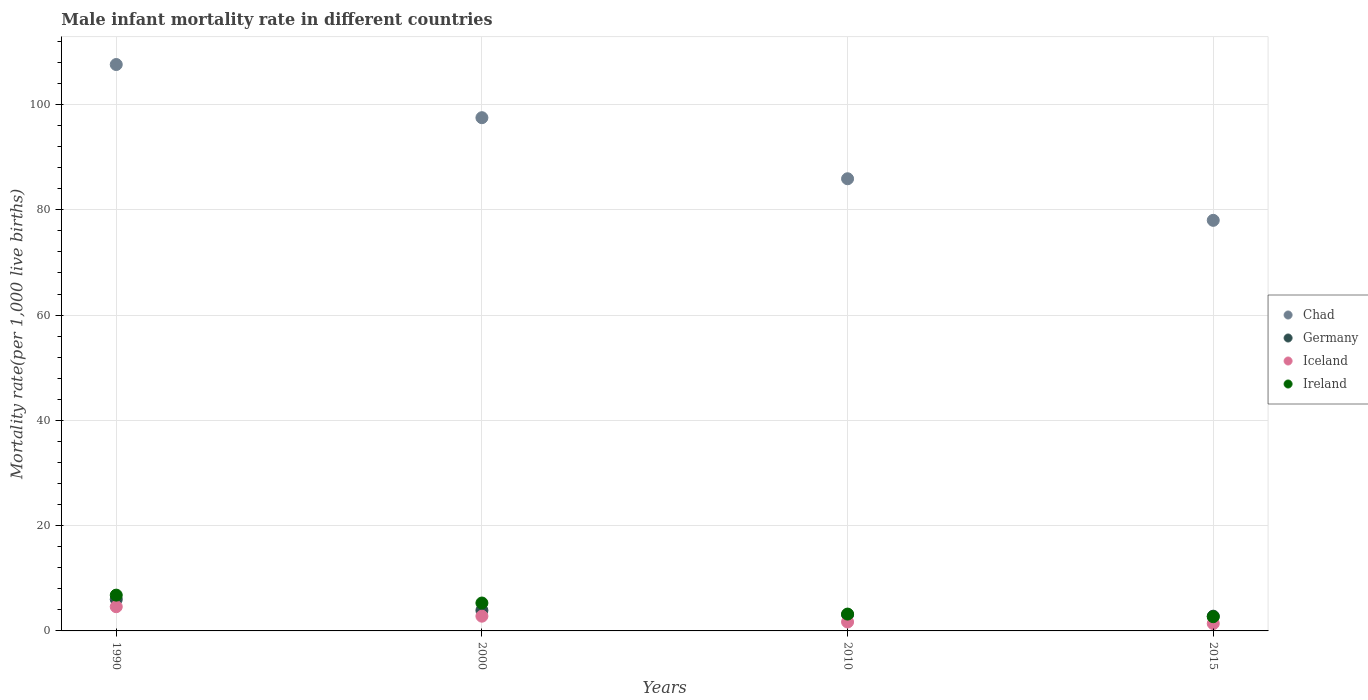What is the male infant mortality rate in Chad in 2010?
Offer a very short reply. 85.9. Across all years, what is the maximum male infant mortality rate in Iceland?
Your answer should be very brief. 4.6. Across all years, what is the minimum male infant mortality rate in Chad?
Provide a short and direct response. 78. In which year was the male infant mortality rate in Germany minimum?
Provide a short and direct response. 2015. What is the total male infant mortality rate in Germany in the graph?
Your answer should be compact. 15.8. What is the difference between the male infant mortality rate in Germany in 1990 and that in 2000?
Your response must be concise. 2.1. What is the difference between the male infant mortality rate in Ireland in 2000 and the male infant mortality rate in Iceland in 2010?
Keep it short and to the point. 3.6. What is the average male infant mortality rate in Chad per year?
Provide a short and direct response. 92.25. In the year 2015, what is the difference between the male infant mortality rate in Germany and male infant mortality rate in Ireland?
Offer a terse response. 0.1. In how many years, is the male infant mortality rate in Ireland greater than 52?
Provide a succinct answer. 0. What is the ratio of the male infant mortality rate in Germany in 1990 to that in 2015?
Your response must be concise. 2.14. Is the male infant mortality rate in Ireland in 1990 less than that in 2010?
Your answer should be very brief. No. Is the difference between the male infant mortality rate in Germany in 2000 and 2010 greater than the difference between the male infant mortality rate in Ireland in 2000 and 2010?
Keep it short and to the point. No. What is the difference between the highest and the second highest male infant mortality rate in Chad?
Your answer should be compact. 10.1. In how many years, is the male infant mortality rate in Iceland greater than the average male infant mortality rate in Iceland taken over all years?
Keep it short and to the point. 2. Is it the case that in every year, the sum of the male infant mortality rate in Ireland and male infant mortality rate in Chad  is greater than the sum of male infant mortality rate in Iceland and male infant mortality rate in Germany?
Your response must be concise. Yes. Does the male infant mortality rate in Germany monotonically increase over the years?
Make the answer very short. No. Is the male infant mortality rate in Chad strictly greater than the male infant mortality rate in Iceland over the years?
Give a very brief answer. Yes. How many dotlines are there?
Provide a short and direct response. 4. How many years are there in the graph?
Offer a very short reply. 4. Does the graph contain any zero values?
Offer a terse response. No. Does the graph contain grids?
Offer a very short reply. Yes. How many legend labels are there?
Your answer should be very brief. 4. How are the legend labels stacked?
Your response must be concise. Vertical. What is the title of the graph?
Ensure brevity in your answer.  Male infant mortality rate in different countries. What is the label or title of the Y-axis?
Keep it short and to the point. Mortality rate(per 1,0 live births). What is the Mortality rate(per 1,000 live births) in Chad in 1990?
Offer a very short reply. 107.6. What is the Mortality rate(per 1,000 live births) in Chad in 2000?
Your answer should be compact. 97.5. What is the Mortality rate(per 1,000 live births) in Iceland in 2000?
Offer a terse response. 2.8. What is the Mortality rate(per 1,000 live births) of Ireland in 2000?
Offer a very short reply. 5.3. What is the Mortality rate(per 1,000 live births) of Chad in 2010?
Ensure brevity in your answer.  85.9. What is the Mortality rate(per 1,000 live births) in Germany in 2010?
Offer a terse response. 3.1. What is the Mortality rate(per 1,000 live births) in Germany in 2015?
Provide a short and direct response. 2.8. Across all years, what is the maximum Mortality rate(per 1,000 live births) of Chad?
Give a very brief answer. 107.6. Across all years, what is the maximum Mortality rate(per 1,000 live births) of Iceland?
Ensure brevity in your answer.  4.6. Across all years, what is the minimum Mortality rate(per 1,000 live births) in Chad?
Your response must be concise. 78. What is the total Mortality rate(per 1,000 live births) of Chad in the graph?
Give a very brief answer. 369. What is the total Mortality rate(per 1,000 live births) of Germany in the graph?
Offer a terse response. 15.8. What is the total Mortality rate(per 1,000 live births) of Iceland in the graph?
Your answer should be compact. 10.5. What is the difference between the Mortality rate(per 1,000 live births) in Chad in 1990 and that in 2000?
Make the answer very short. 10.1. What is the difference between the Mortality rate(per 1,000 live births) of Germany in 1990 and that in 2000?
Offer a very short reply. 2.1. What is the difference between the Mortality rate(per 1,000 live births) in Ireland in 1990 and that in 2000?
Your answer should be very brief. 1.5. What is the difference between the Mortality rate(per 1,000 live births) of Chad in 1990 and that in 2010?
Your response must be concise. 21.7. What is the difference between the Mortality rate(per 1,000 live births) in Iceland in 1990 and that in 2010?
Your response must be concise. 2.9. What is the difference between the Mortality rate(per 1,000 live births) of Ireland in 1990 and that in 2010?
Offer a terse response. 3.6. What is the difference between the Mortality rate(per 1,000 live births) in Chad in 1990 and that in 2015?
Your answer should be very brief. 29.6. What is the difference between the Mortality rate(per 1,000 live births) of Germany in 1990 and that in 2015?
Offer a very short reply. 3.2. What is the difference between the Mortality rate(per 1,000 live births) in Germany in 2000 and that in 2010?
Your response must be concise. 0.8. What is the difference between the Mortality rate(per 1,000 live births) in Ireland in 2000 and that in 2010?
Your response must be concise. 2.1. What is the difference between the Mortality rate(per 1,000 live births) of Germany in 2010 and that in 2015?
Provide a short and direct response. 0.3. What is the difference between the Mortality rate(per 1,000 live births) in Ireland in 2010 and that in 2015?
Provide a succinct answer. 0.5. What is the difference between the Mortality rate(per 1,000 live births) in Chad in 1990 and the Mortality rate(per 1,000 live births) in Germany in 2000?
Keep it short and to the point. 103.7. What is the difference between the Mortality rate(per 1,000 live births) of Chad in 1990 and the Mortality rate(per 1,000 live births) of Iceland in 2000?
Your response must be concise. 104.8. What is the difference between the Mortality rate(per 1,000 live births) in Chad in 1990 and the Mortality rate(per 1,000 live births) in Ireland in 2000?
Make the answer very short. 102.3. What is the difference between the Mortality rate(per 1,000 live births) in Germany in 1990 and the Mortality rate(per 1,000 live births) in Ireland in 2000?
Offer a terse response. 0.7. What is the difference between the Mortality rate(per 1,000 live births) in Chad in 1990 and the Mortality rate(per 1,000 live births) in Germany in 2010?
Your answer should be very brief. 104.5. What is the difference between the Mortality rate(per 1,000 live births) in Chad in 1990 and the Mortality rate(per 1,000 live births) in Iceland in 2010?
Make the answer very short. 105.9. What is the difference between the Mortality rate(per 1,000 live births) in Chad in 1990 and the Mortality rate(per 1,000 live births) in Ireland in 2010?
Keep it short and to the point. 104.4. What is the difference between the Mortality rate(per 1,000 live births) in Germany in 1990 and the Mortality rate(per 1,000 live births) in Iceland in 2010?
Your answer should be very brief. 4.3. What is the difference between the Mortality rate(per 1,000 live births) of Iceland in 1990 and the Mortality rate(per 1,000 live births) of Ireland in 2010?
Make the answer very short. 1.4. What is the difference between the Mortality rate(per 1,000 live births) of Chad in 1990 and the Mortality rate(per 1,000 live births) of Germany in 2015?
Offer a terse response. 104.8. What is the difference between the Mortality rate(per 1,000 live births) in Chad in 1990 and the Mortality rate(per 1,000 live births) in Iceland in 2015?
Give a very brief answer. 106.2. What is the difference between the Mortality rate(per 1,000 live births) in Chad in 1990 and the Mortality rate(per 1,000 live births) in Ireland in 2015?
Offer a terse response. 104.9. What is the difference between the Mortality rate(per 1,000 live births) of Germany in 1990 and the Mortality rate(per 1,000 live births) of Iceland in 2015?
Provide a succinct answer. 4.6. What is the difference between the Mortality rate(per 1,000 live births) in Germany in 1990 and the Mortality rate(per 1,000 live births) in Ireland in 2015?
Provide a succinct answer. 3.3. What is the difference between the Mortality rate(per 1,000 live births) in Iceland in 1990 and the Mortality rate(per 1,000 live births) in Ireland in 2015?
Make the answer very short. 1.9. What is the difference between the Mortality rate(per 1,000 live births) of Chad in 2000 and the Mortality rate(per 1,000 live births) of Germany in 2010?
Your response must be concise. 94.4. What is the difference between the Mortality rate(per 1,000 live births) in Chad in 2000 and the Mortality rate(per 1,000 live births) in Iceland in 2010?
Your answer should be compact. 95.8. What is the difference between the Mortality rate(per 1,000 live births) in Chad in 2000 and the Mortality rate(per 1,000 live births) in Ireland in 2010?
Your answer should be compact. 94.3. What is the difference between the Mortality rate(per 1,000 live births) in Germany in 2000 and the Mortality rate(per 1,000 live births) in Iceland in 2010?
Provide a succinct answer. 2.2. What is the difference between the Mortality rate(per 1,000 live births) in Germany in 2000 and the Mortality rate(per 1,000 live births) in Ireland in 2010?
Keep it short and to the point. 0.7. What is the difference between the Mortality rate(per 1,000 live births) in Chad in 2000 and the Mortality rate(per 1,000 live births) in Germany in 2015?
Offer a very short reply. 94.7. What is the difference between the Mortality rate(per 1,000 live births) in Chad in 2000 and the Mortality rate(per 1,000 live births) in Iceland in 2015?
Your answer should be compact. 96.1. What is the difference between the Mortality rate(per 1,000 live births) in Chad in 2000 and the Mortality rate(per 1,000 live births) in Ireland in 2015?
Provide a short and direct response. 94.8. What is the difference between the Mortality rate(per 1,000 live births) of Iceland in 2000 and the Mortality rate(per 1,000 live births) of Ireland in 2015?
Give a very brief answer. 0.1. What is the difference between the Mortality rate(per 1,000 live births) in Chad in 2010 and the Mortality rate(per 1,000 live births) in Germany in 2015?
Give a very brief answer. 83.1. What is the difference between the Mortality rate(per 1,000 live births) in Chad in 2010 and the Mortality rate(per 1,000 live births) in Iceland in 2015?
Keep it short and to the point. 84.5. What is the difference between the Mortality rate(per 1,000 live births) of Chad in 2010 and the Mortality rate(per 1,000 live births) of Ireland in 2015?
Give a very brief answer. 83.2. What is the average Mortality rate(per 1,000 live births) of Chad per year?
Give a very brief answer. 92.25. What is the average Mortality rate(per 1,000 live births) of Germany per year?
Keep it short and to the point. 3.95. What is the average Mortality rate(per 1,000 live births) in Iceland per year?
Give a very brief answer. 2.62. What is the average Mortality rate(per 1,000 live births) of Ireland per year?
Give a very brief answer. 4.5. In the year 1990, what is the difference between the Mortality rate(per 1,000 live births) in Chad and Mortality rate(per 1,000 live births) in Germany?
Ensure brevity in your answer.  101.6. In the year 1990, what is the difference between the Mortality rate(per 1,000 live births) in Chad and Mortality rate(per 1,000 live births) in Iceland?
Your answer should be very brief. 103. In the year 1990, what is the difference between the Mortality rate(per 1,000 live births) of Chad and Mortality rate(per 1,000 live births) of Ireland?
Provide a succinct answer. 100.8. In the year 1990, what is the difference between the Mortality rate(per 1,000 live births) of Germany and Mortality rate(per 1,000 live births) of Iceland?
Offer a very short reply. 1.4. In the year 2000, what is the difference between the Mortality rate(per 1,000 live births) in Chad and Mortality rate(per 1,000 live births) in Germany?
Offer a very short reply. 93.6. In the year 2000, what is the difference between the Mortality rate(per 1,000 live births) of Chad and Mortality rate(per 1,000 live births) of Iceland?
Keep it short and to the point. 94.7. In the year 2000, what is the difference between the Mortality rate(per 1,000 live births) of Chad and Mortality rate(per 1,000 live births) of Ireland?
Make the answer very short. 92.2. In the year 2000, what is the difference between the Mortality rate(per 1,000 live births) of Germany and Mortality rate(per 1,000 live births) of Iceland?
Offer a very short reply. 1.1. In the year 2000, what is the difference between the Mortality rate(per 1,000 live births) in Germany and Mortality rate(per 1,000 live births) in Ireland?
Provide a succinct answer. -1.4. In the year 2000, what is the difference between the Mortality rate(per 1,000 live births) of Iceland and Mortality rate(per 1,000 live births) of Ireland?
Your answer should be compact. -2.5. In the year 2010, what is the difference between the Mortality rate(per 1,000 live births) of Chad and Mortality rate(per 1,000 live births) of Germany?
Offer a terse response. 82.8. In the year 2010, what is the difference between the Mortality rate(per 1,000 live births) in Chad and Mortality rate(per 1,000 live births) in Iceland?
Your answer should be compact. 84.2. In the year 2010, what is the difference between the Mortality rate(per 1,000 live births) in Chad and Mortality rate(per 1,000 live births) in Ireland?
Keep it short and to the point. 82.7. In the year 2010, what is the difference between the Mortality rate(per 1,000 live births) in Germany and Mortality rate(per 1,000 live births) in Iceland?
Your answer should be compact. 1.4. In the year 2010, what is the difference between the Mortality rate(per 1,000 live births) of Germany and Mortality rate(per 1,000 live births) of Ireland?
Ensure brevity in your answer.  -0.1. In the year 2010, what is the difference between the Mortality rate(per 1,000 live births) of Iceland and Mortality rate(per 1,000 live births) of Ireland?
Make the answer very short. -1.5. In the year 2015, what is the difference between the Mortality rate(per 1,000 live births) in Chad and Mortality rate(per 1,000 live births) in Germany?
Offer a terse response. 75.2. In the year 2015, what is the difference between the Mortality rate(per 1,000 live births) in Chad and Mortality rate(per 1,000 live births) in Iceland?
Keep it short and to the point. 76.6. In the year 2015, what is the difference between the Mortality rate(per 1,000 live births) of Chad and Mortality rate(per 1,000 live births) of Ireland?
Your answer should be compact. 75.3. What is the ratio of the Mortality rate(per 1,000 live births) of Chad in 1990 to that in 2000?
Offer a very short reply. 1.1. What is the ratio of the Mortality rate(per 1,000 live births) of Germany in 1990 to that in 2000?
Your answer should be very brief. 1.54. What is the ratio of the Mortality rate(per 1,000 live births) of Iceland in 1990 to that in 2000?
Your answer should be compact. 1.64. What is the ratio of the Mortality rate(per 1,000 live births) of Ireland in 1990 to that in 2000?
Offer a terse response. 1.28. What is the ratio of the Mortality rate(per 1,000 live births) in Chad in 1990 to that in 2010?
Your answer should be very brief. 1.25. What is the ratio of the Mortality rate(per 1,000 live births) of Germany in 1990 to that in 2010?
Offer a very short reply. 1.94. What is the ratio of the Mortality rate(per 1,000 live births) of Iceland in 1990 to that in 2010?
Your answer should be very brief. 2.71. What is the ratio of the Mortality rate(per 1,000 live births) of Ireland in 1990 to that in 2010?
Your answer should be compact. 2.12. What is the ratio of the Mortality rate(per 1,000 live births) of Chad in 1990 to that in 2015?
Your answer should be very brief. 1.38. What is the ratio of the Mortality rate(per 1,000 live births) of Germany in 1990 to that in 2015?
Provide a short and direct response. 2.14. What is the ratio of the Mortality rate(per 1,000 live births) of Iceland in 1990 to that in 2015?
Your answer should be very brief. 3.29. What is the ratio of the Mortality rate(per 1,000 live births) in Ireland in 1990 to that in 2015?
Offer a terse response. 2.52. What is the ratio of the Mortality rate(per 1,000 live births) in Chad in 2000 to that in 2010?
Your answer should be compact. 1.14. What is the ratio of the Mortality rate(per 1,000 live births) of Germany in 2000 to that in 2010?
Make the answer very short. 1.26. What is the ratio of the Mortality rate(per 1,000 live births) in Iceland in 2000 to that in 2010?
Make the answer very short. 1.65. What is the ratio of the Mortality rate(per 1,000 live births) of Ireland in 2000 to that in 2010?
Your answer should be compact. 1.66. What is the ratio of the Mortality rate(per 1,000 live births) of Germany in 2000 to that in 2015?
Ensure brevity in your answer.  1.39. What is the ratio of the Mortality rate(per 1,000 live births) of Iceland in 2000 to that in 2015?
Provide a short and direct response. 2. What is the ratio of the Mortality rate(per 1,000 live births) in Ireland in 2000 to that in 2015?
Provide a short and direct response. 1.96. What is the ratio of the Mortality rate(per 1,000 live births) in Chad in 2010 to that in 2015?
Your answer should be very brief. 1.1. What is the ratio of the Mortality rate(per 1,000 live births) in Germany in 2010 to that in 2015?
Keep it short and to the point. 1.11. What is the ratio of the Mortality rate(per 1,000 live births) in Iceland in 2010 to that in 2015?
Your answer should be very brief. 1.21. What is the ratio of the Mortality rate(per 1,000 live births) of Ireland in 2010 to that in 2015?
Provide a short and direct response. 1.19. What is the difference between the highest and the second highest Mortality rate(per 1,000 live births) of Ireland?
Make the answer very short. 1.5. What is the difference between the highest and the lowest Mortality rate(per 1,000 live births) in Chad?
Offer a very short reply. 29.6. What is the difference between the highest and the lowest Mortality rate(per 1,000 live births) of Germany?
Give a very brief answer. 3.2. 